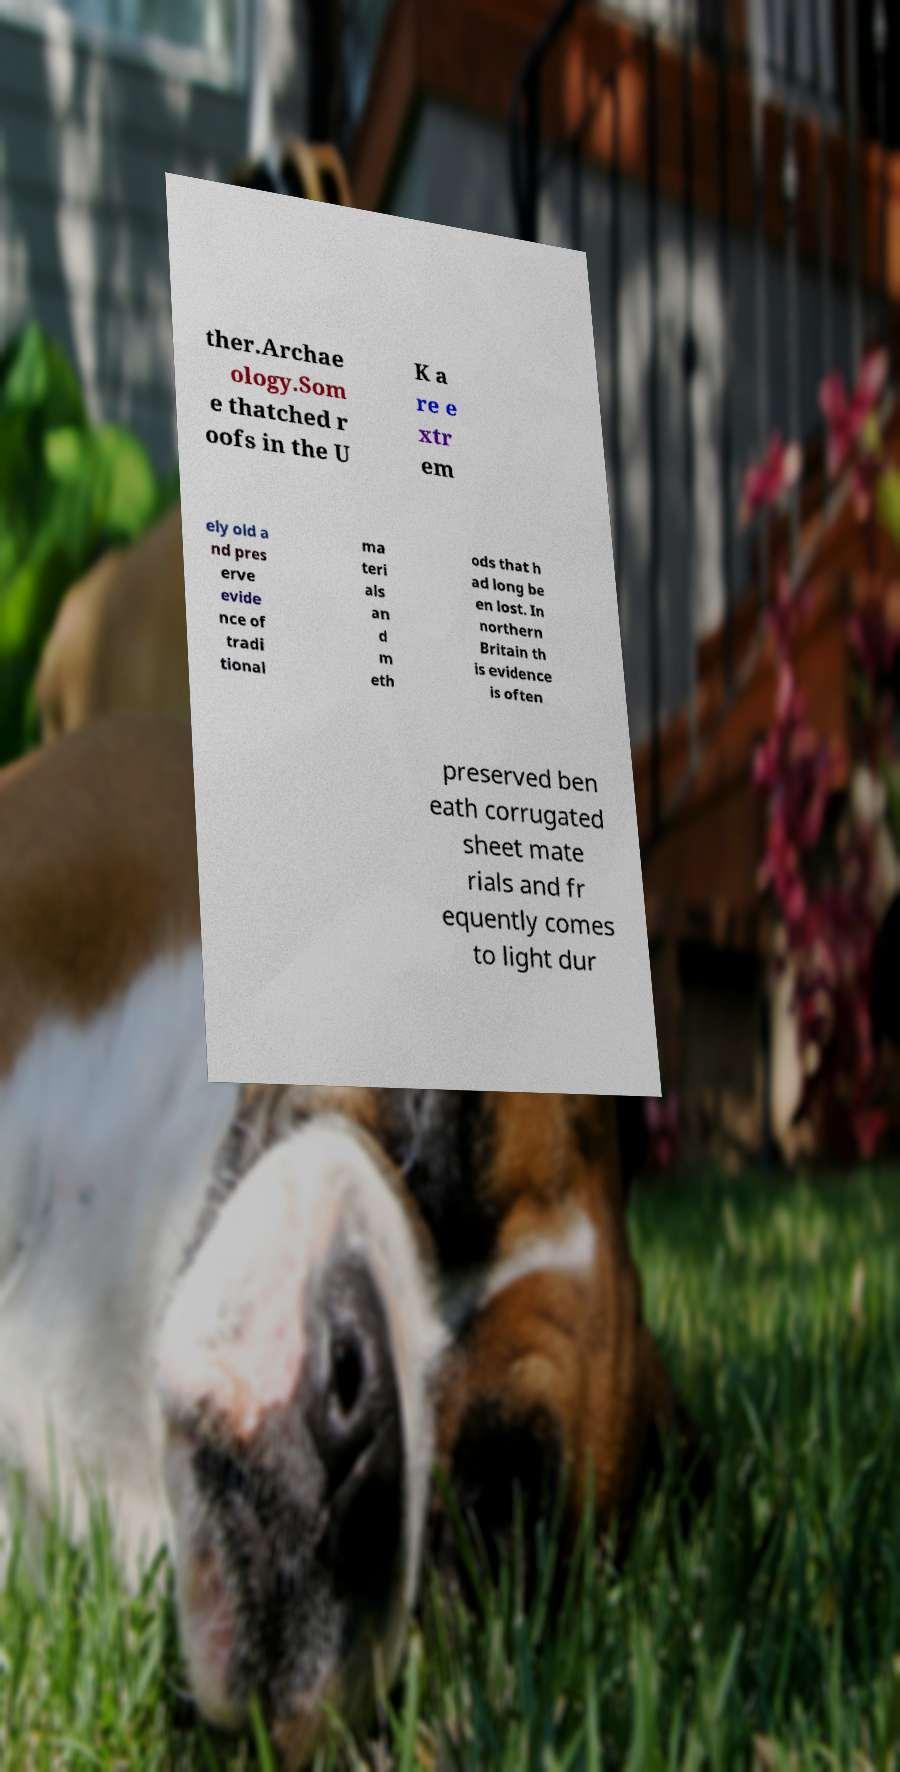I need the written content from this picture converted into text. Can you do that? ther.Archae ology.Som e thatched r oofs in the U K a re e xtr em ely old a nd pres erve evide nce of tradi tional ma teri als an d m eth ods that h ad long be en lost. In northern Britain th is evidence is often preserved ben eath corrugated sheet mate rials and fr equently comes to light dur 